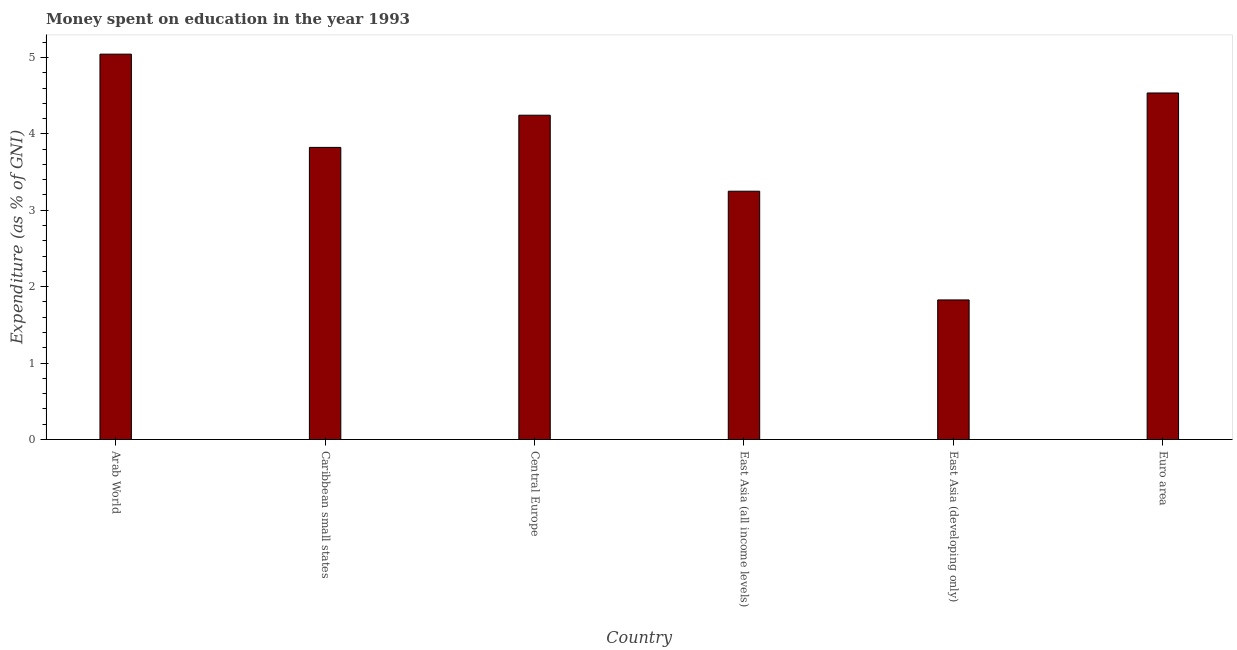What is the title of the graph?
Make the answer very short. Money spent on education in the year 1993. What is the label or title of the X-axis?
Your response must be concise. Country. What is the label or title of the Y-axis?
Ensure brevity in your answer.  Expenditure (as % of GNI). What is the expenditure on education in Caribbean small states?
Make the answer very short. 3.82. Across all countries, what is the maximum expenditure on education?
Your response must be concise. 5.04. Across all countries, what is the minimum expenditure on education?
Offer a terse response. 1.83. In which country was the expenditure on education maximum?
Your response must be concise. Arab World. In which country was the expenditure on education minimum?
Your answer should be compact. East Asia (developing only). What is the sum of the expenditure on education?
Offer a terse response. 22.72. What is the difference between the expenditure on education in East Asia (developing only) and Euro area?
Offer a very short reply. -2.71. What is the average expenditure on education per country?
Provide a succinct answer. 3.79. What is the median expenditure on education?
Your answer should be very brief. 4.03. What is the ratio of the expenditure on education in Caribbean small states to that in Euro area?
Your answer should be very brief. 0.84. Is the expenditure on education in Caribbean small states less than that in Euro area?
Provide a succinct answer. Yes. Is the difference between the expenditure on education in Arab World and Caribbean small states greater than the difference between any two countries?
Make the answer very short. No. What is the difference between the highest and the second highest expenditure on education?
Offer a terse response. 0.51. What is the difference between the highest and the lowest expenditure on education?
Give a very brief answer. 3.22. How many bars are there?
Make the answer very short. 6. How many countries are there in the graph?
Provide a short and direct response. 6. What is the difference between two consecutive major ticks on the Y-axis?
Provide a short and direct response. 1. What is the Expenditure (as % of GNI) in Arab World?
Give a very brief answer. 5.04. What is the Expenditure (as % of GNI) of Caribbean small states?
Your response must be concise. 3.82. What is the Expenditure (as % of GNI) in Central Europe?
Provide a short and direct response. 4.24. What is the Expenditure (as % of GNI) of East Asia (all income levels)?
Offer a terse response. 3.25. What is the Expenditure (as % of GNI) in East Asia (developing only)?
Provide a short and direct response. 1.83. What is the Expenditure (as % of GNI) in Euro area?
Your answer should be very brief. 4.53. What is the difference between the Expenditure (as % of GNI) in Arab World and Caribbean small states?
Offer a very short reply. 1.22. What is the difference between the Expenditure (as % of GNI) in Arab World and Central Europe?
Your response must be concise. 0.8. What is the difference between the Expenditure (as % of GNI) in Arab World and East Asia (all income levels)?
Your answer should be compact. 1.79. What is the difference between the Expenditure (as % of GNI) in Arab World and East Asia (developing only)?
Your answer should be compact. 3.22. What is the difference between the Expenditure (as % of GNI) in Arab World and Euro area?
Your answer should be very brief. 0.51. What is the difference between the Expenditure (as % of GNI) in Caribbean small states and Central Europe?
Give a very brief answer. -0.42. What is the difference between the Expenditure (as % of GNI) in Caribbean small states and East Asia (all income levels)?
Your answer should be compact. 0.57. What is the difference between the Expenditure (as % of GNI) in Caribbean small states and East Asia (developing only)?
Your answer should be very brief. 2. What is the difference between the Expenditure (as % of GNI) in Caribbean small states and Euro area?
Your answer should be compact. -0.71. What is the difference between the Expenditure (as % of GNI) in Central Europe and East Asia (all income levels)?
Provide a short and direct response. 0.99. What is the difference between the Expenditure (as % of GNI) in Central Europe and East Asia (developing only)?
Your response must be concise. 2.42. What is the difference between the Expenditure (as % of GNI) in Central Europe and Euro area?
Your response must be concise. -0.29. What is the difference between the Expenditure (as % of GNI) in East Asia (all income levels) and East Asia (developing only)?
Provide a succinct answer. 1.42. What is the difference between the Expenditure (as % of GNI) in East Asia (all income levels) and Euro area?
Provide a succinct answer. -1.29. What is the difference between the Expenditure (as % of GNI) in East Asia (developing only) and Euro area?
Ensure brevity in your answer.  -2.71. What is the ratio of the Expenditure (as % of GNI) in Arab World to that in Caribbean small states?
Ensure brevity in your answer.  1.32. What is the ratio of the Expenditure (as % of GNI) in Arab World to that in Central Europe?
Your answer should be compact. 1.19. What is the ratio of the Expenditure (as % of GNI) in Arab World to that in East Asia (all income levels)?
Keep it short and to the point. 1.55. What is the ratio of the Expenditure (as % of GNI) in Arab World to that in East Asia (developing only)?
Provide a short and direct response. 2.76. What is the ratio of the Expenditure (as % of GNI) in Arab World to that in Euro area?
Make the answer very short. 1.11. What is the ratio of the Expenditure (as % of GNI) in Caribbean small states to that in Central Europe?
Keep it short and to the point. 0.9. What is the ratio of the Expenditure (as % of GNI) in Caribbean small states to that in East Asia (all income levels)?
Provide a short and direct response. 1.18. What is the ratio of the Expenditure (as % of GNI) in Caribbean small states to that in East Asia (developing only)?
Provide a succinct answer. 2.09. What is the ratio of the Expenditure (as % of GNI) in Caribbean small states to that in Euro area?
Give a very brief answer. 0.84. What is the ratio of the Expenditure (as % of GNI) in Central Europe to that in East Asia (all income levels)?
Your answer should be compact. 1.31. What is the ratio of the Expenditure (as % of GNI) in Central Europe to that in East Asia (developing only)?
Give a very brief answer. 2.32. What is the ratio of the Expenditure (as % of GNI) in Central Europe to that in Euro area?
Offer a terse response. 0.94. What is the ratio of the Expenditure (as % of GNI) in East Asia (all income levels) to that in East Asia (developing only)?
Provide a short and direct response. 1.78. What is the ratio of the Expenditure (as % of GNI) in East Asia (all income levels) to that in Euro area?
Ensure brevity in your answer.  0.72. What is the ratio of the Expenditure (as % of GNI) in East Asia (developing only) to that in Euro area?
Provide a short and direct response. 0.4. 